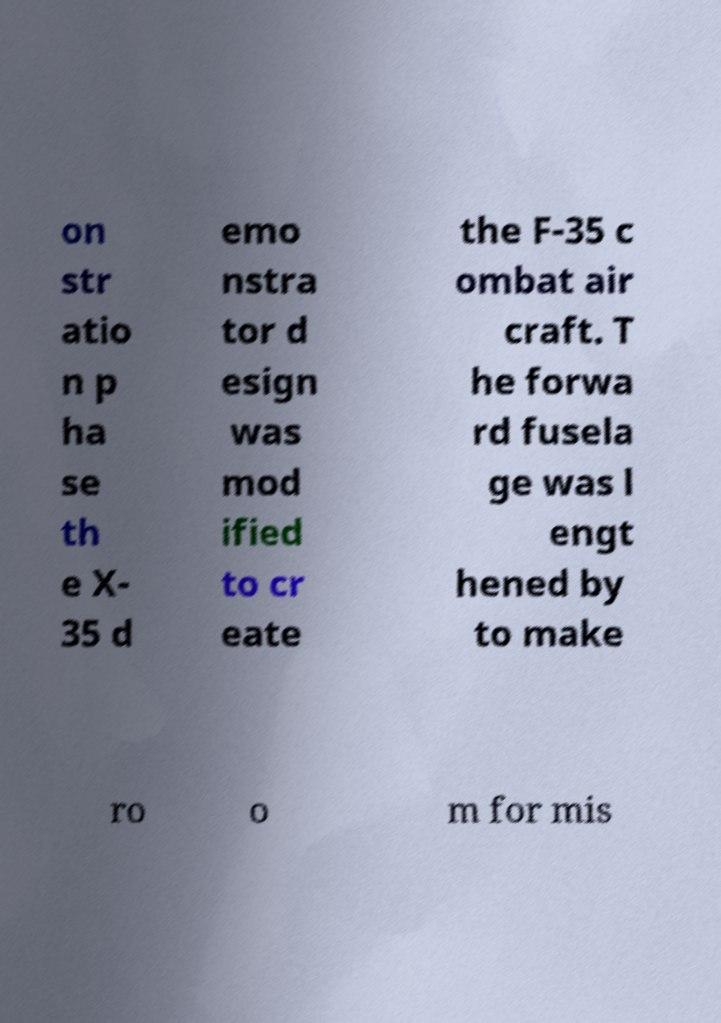Could you extract and type out the text from this image? on str atio n p ha se th e X- 35 d emo nstra tor d esign was mod ified to cr eate the F-35 c ombat air craft. T he forwa rd fusela ge was l engt hened by to make ro o m for mis 